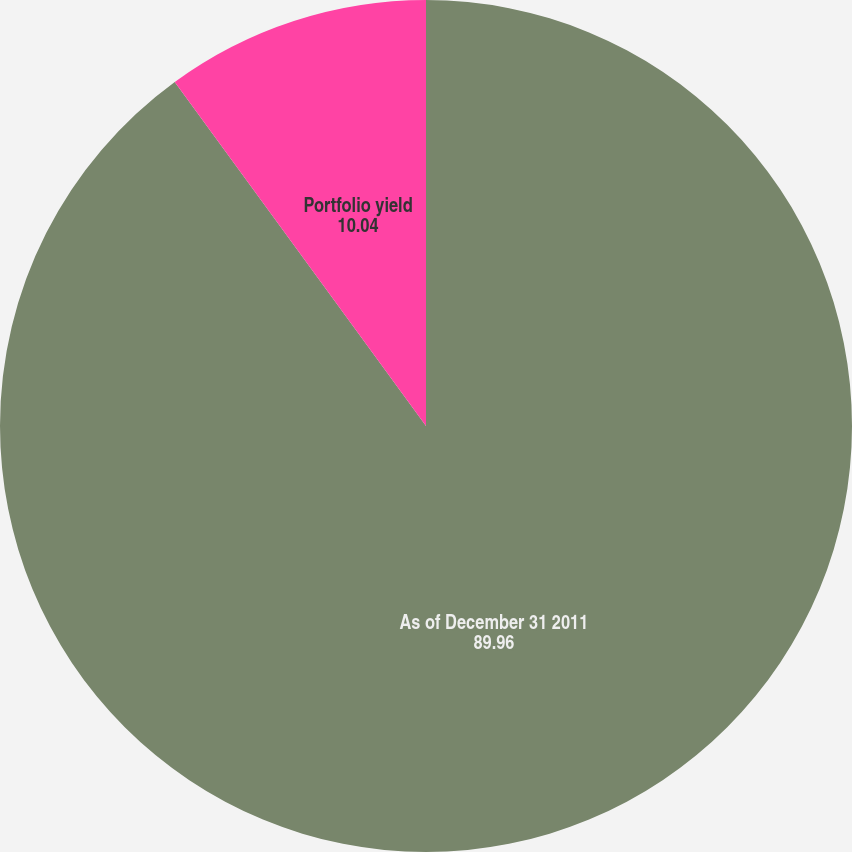Convert chart to OTSL. <chart><loc_0><loc_0><loc_500><loc_500><pie_chart><fcel>As of December 31 2011<fcel>Portfolio yield<nl><fcel>89.96%<fcel>10.04%<nl></chart> 